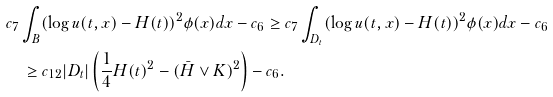<formula> <loc_0><loc_0><loc_500><loc_500>& c _ { 7 } \int _ { B } ( \log u ( t , x ) - H ( t ) ) ^ { 2 } \phi ( x ) d x - c _ { 6 } \geq c _ { 7 } \int _ { D _ { t } } ( \log u ( t , x ) - H ( t ) ) ^ { 2 } \phi ( x ) d x - c _ { 6 } \\ & \quad \geq c _ { 1 2 } | D _ { t } | \left ( \frac { 1 } { 4 } H ( t ) ^ { 2 } - ( \bar { H } \lor K ) ^ { 2 } \right ) - c _ { 6 } .</formula> 